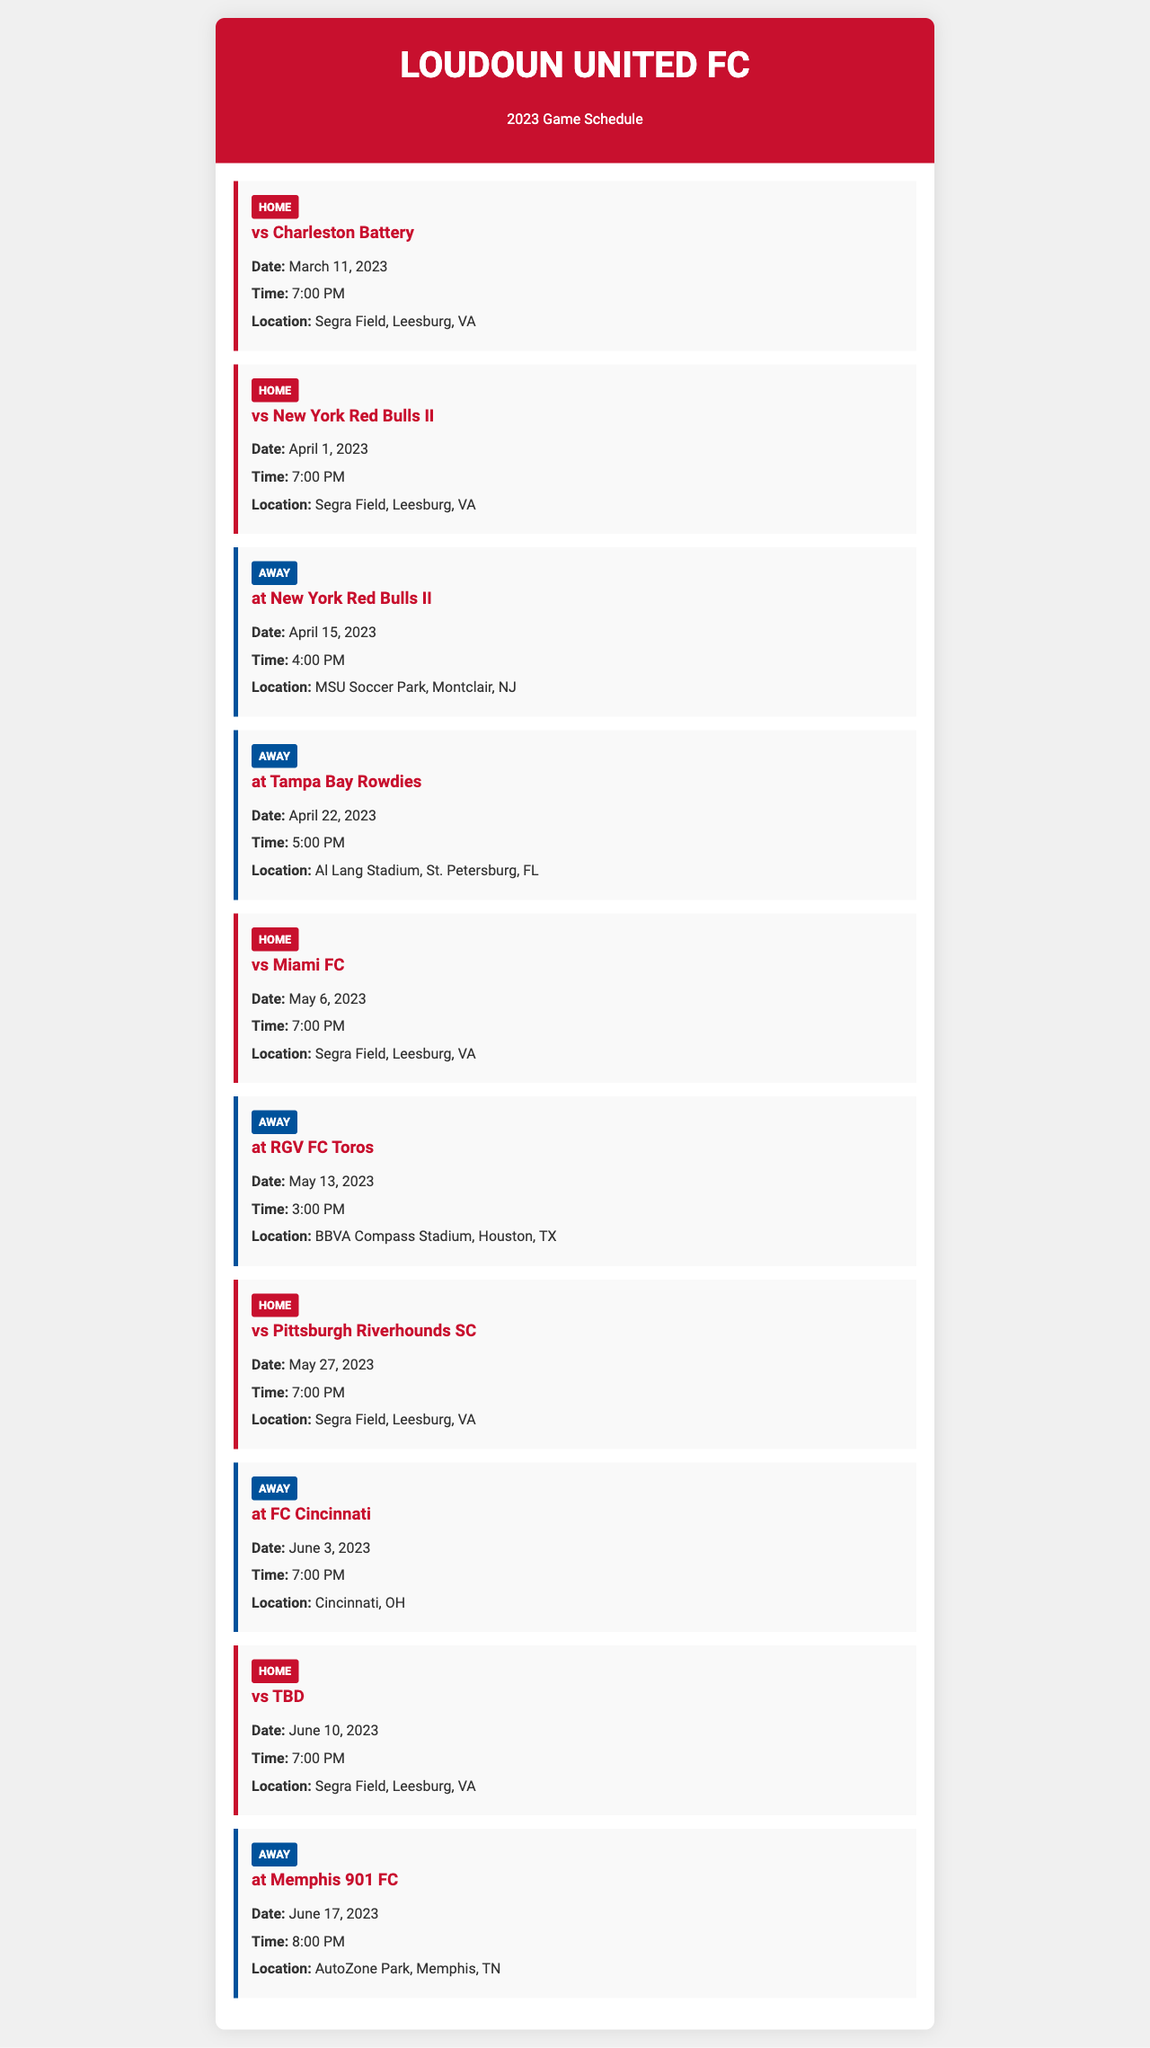What is the first home game of the season? The first home game is against Charleston Battery, which is the first match listed in the schedule.
Answer: vs Charleston Battery What is the date of the match against the New York Red Bulls II? The document lists the match against New York Red Bulls II on April 1, 2023.
Answer: April 1, 2023 How many away games are scheduled in May 2023? The document shows two away games scheduled in May 2023: at RGV FC Toros and at Tampa Bay Rowdies.
Answer: 2 What time does the away match at Tampa Bay Rowdies start? The time of the match at Tampa Bay Rowdies is mentioned in the document as 5:00 PM.
Answer: 5:00 PM Where will the match on June 10, 2023, take place? This match is a home game, and the document specifies the location as Segra Field, Leesburg, VA.
Answer: Segra Field, Leesburg, VA Which team will Loudoun United FC face on May 27, 2023? The match on May 27, 2023, is against Pittsburgh Riverhounds SC, as indicated in the document.
Answer: vs Pittsburgh Riverhounds SC How many total home matches are listed in the document? The document details five home matches for Loudoun United FC.
Answer: 5 What color represents away games in the schedule? The document uses blue (#00529B) for the border of away games, as indicated in its styling.
Answer: Blue 